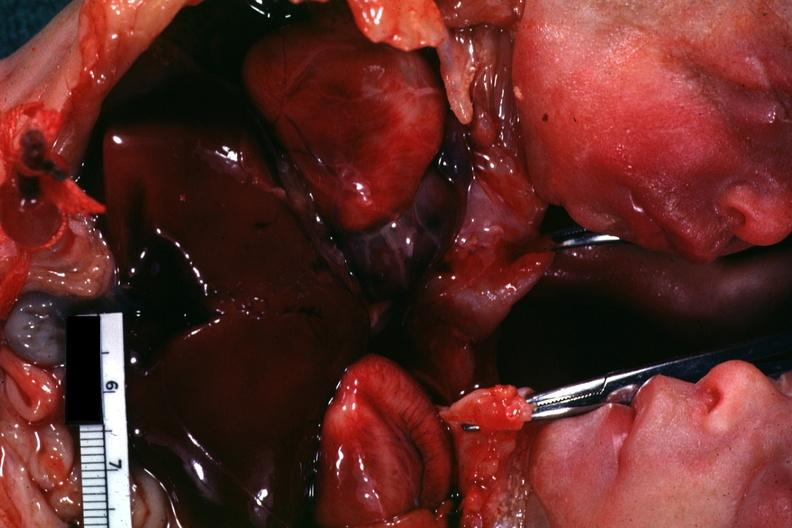s this joined chest and abdomen slide shows opened chest with two hearts?
Answer the question using a single word or phrase. Yes 